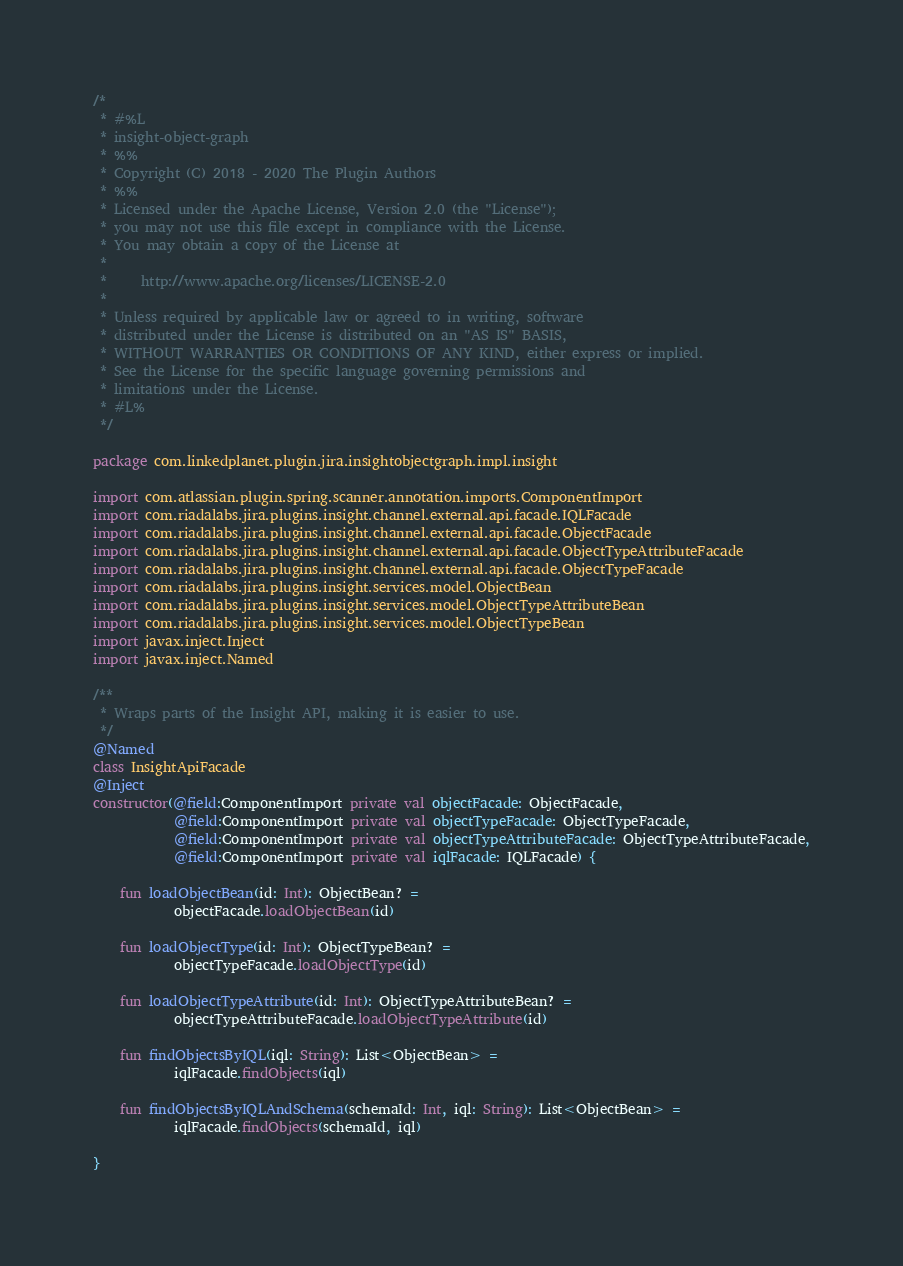Convert code to text. <code><loc_0><loc_0><loc_500><loc_500><_Kotlin_>/*
 * #%L
 * insight-object-graph
 * %%
 * Copyright (C) 2018 - 2020 The Plugin Authors
 * %%
 * Licensed under the Apache License, Version 2.0 (the "License");
 * you may not use this file except in compliance with the License.
 * You may obtain a copy of the License at
 *
 *     http://www.apache.org/licenses/LICENSE-2.0
 *
 * Unless required by applicable law or agreed to in writing, software
 * distributed under the License is distributed on an "AS IS" BASIS,
 * WITHOUT WARRANTIES OR CONDITIONS OF ANY KIND, either express or implied.
 * See the License for the specific language governing permissions and
 * limitations under the License.
 * #L%
 */

package com.linkedplanet.plugin.jira.insightobjectgraph.impl.insight

import com.atlassian.plugin.spring.scanner.annotation.imports.ComponentImport
import com.riadalabs.jira.plugins.insight.channel.external.api.facade.IQLFacade
import com.riadalabs.jira.plugins.insight.channel.external.api.facade.ObjectFacade
import com.riadalabs.jira.plugins.insight.channel.external.api.facade.ObjectTypeAttributeFacade
import com.riadalabs.jira.plugins.insight.channel.external.api.facade.ObjectTypeFacade
import com.riadalabs.jira.plugins.insight.services.model.ObjectBean
import com.riadalabs.jira.plugins.insight.services.model.ObjectTypeAttributeBean
import com.riadalabs.jira.plugins.insight.services.model.ObjectTypeBean
import javax.inject.Inject
import javax.inject.Named

/**
 * Wraps parts of the Insight API, making it is easier to use.
 */
@Named
class InsightApiFacade
@Inject
constructor(@field:ComponentImport private val objectFacade: ObjectFacade,
            @field:ComponentImport private val objectTypeFacade: ObjectTypeFacade,
            @field:ComponentImport private val objectTypeAttributeFacade: ObjectTypeAttributeFacade,
            @field:ComponentImport private val iqlFacade: IQLFacade) {

    fun loadObjectBean(id: Int): ObjectBean? =
            objectFacade.loadObjectBean(id)

    fun loadObjectType(id: Int): ObjectTypeBean? =
            objectTypeFacade.loadObjectType(id)

    fun loadObjectTypeAttribute(id: Int): ObjectTypeAttributeBean? =
            objectTypeAttributeFacade.loadObjectTypeAttribute(id)

    fun findObjectsByIQL(iql: String): List<ObjectBean> =
            iqlFacade.findObjects(iql)

    fun findObjectsByIQLAndSchema(schemaId: Int, iql: String): List<ObjectBean> =
            iqlFacade.findObjects(schemaId, iql)

}
</code> 